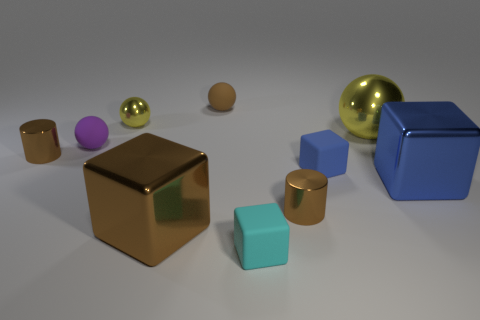What shape is the tiny brown shiny object to the right of the brown cylinder on the left side of the matte thing on the left side of the brown block?
Provide a succinct answer. Cylinder. There is a purple rubber sphere; is it the same size as the cube to the left of the tiny brown matte thing?
Give a very brief answer. No. Is there a yellow ball that has the same size as the cyan rubber object?
Provide a succinct answer. Yes. How many other objects are the same material as the large blue cube?
Your answer should be compact. 5. What is the color of the large metallic thing that is right of the tiny cyan rubber cube and left of the large blue metal cube?
Make the answer very short. Yellow. Do the small brown cylinder to the left of the big brown cube and the yellow ball that is in front of the small yellow shiny object have the same material?
Your answer should be very brief. Yes. Does the rubber sphere behind the purple object have the same size as the tiny cyan matte cube?
Provide a succinct answer. Yes. Does the big sphere have the same color as the big cube that is on the left side of the small blue cube?
Offer a very short reply. No. There is a small object that is the same color as the large ball; what is its shape?
Keep it short and to the point. Sphere. What shape is the small purple matte object?
Your answer should be compact. Sphere. 